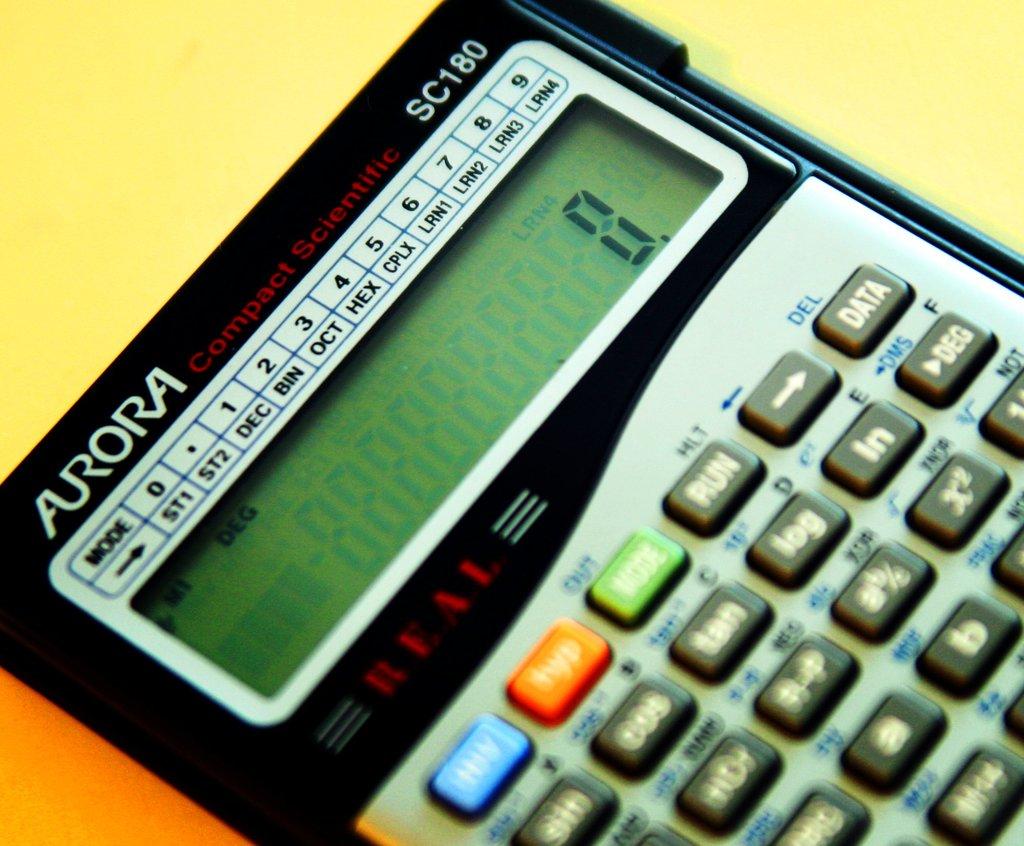What is the calculator brand?
Provide a short and direct response. Aurora. What model number is this calculator?
Keep it short and to the point. Sc180. 